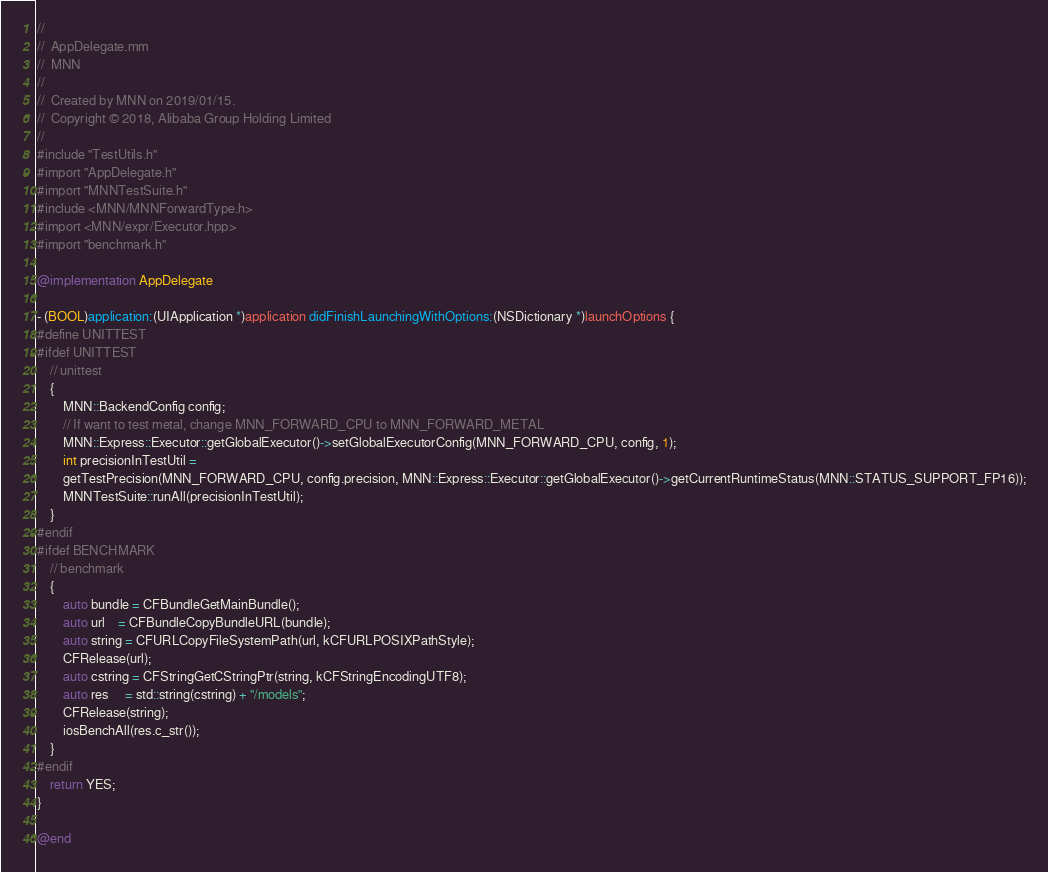Convert code to text. <code><loc_0><loc_0><loc_500><loc_500><_ObjectiveC_>//
//  AppDelegate.mm
//  MNN
//
//  Created by MNN on 2019/01/15.
//  Copyright © 2018, Alibaba Group Holding Limited
//
#include "TestUtils.h"
#import "AppDelegate.h"
#import "MNNTestSuite.h"
#include <MNN/MNNForwardType.h>
#import <MNN/expr/Executor.hpp>
#import "benchmark.h"

@implementation AppDelegate

- (BOOL)application:(UIApplication *)application didFinishLaunchingWithOptions:(NSDictionary *)launchOptions {
#define UNITTEST
#ifdef UNITTEST
    // unittest
    {
        MNN::BackendConfig config;
        // If want to test metal, change MNN_FORWARD_CPU to MNN_FORWARD_METAL
        MNN::Express::Executor::getGlobalExecutor()->setGlobalExecutorConfig(MNN_FORWARD_CPU, config, 1);
        int precisionInTestUtil =
        getTestPrecision(MNN_FORWARD_CPU, config.precision, MNN::Express::Executor::getGlobalExecutor()->getCurrentRuntimeStatus(MNN::STATUS_SUPPORT_FP16));
        MNNTestSuite::runAll(precisionInTestUtil);
    }
#endif
#ifdef BENCHMARK
    // benchmark
    {
        auto bundle = CFBundleGetMainBundle();
        auto url    = CFBundleCopyBundleURL(bundle);
        auto string = CFURLCopyFileSystemPath(url, kCFURLPOSIXPathStyle);
        CFRelease(url);
        auto cstring = CFStringGetCStringPtr(string, kCFStringEncodingUTF8);
        auto res     = std::string(cstring) + "/models";
        CFRelease(string);
        iosBenchAll(res.c_str());
    }
#endif
    return YES;
}

@end
</code> 